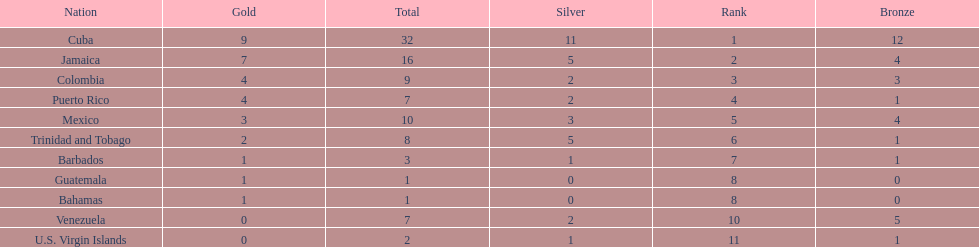What is the total number of gold medals awarded between these 11 countries? 32. 